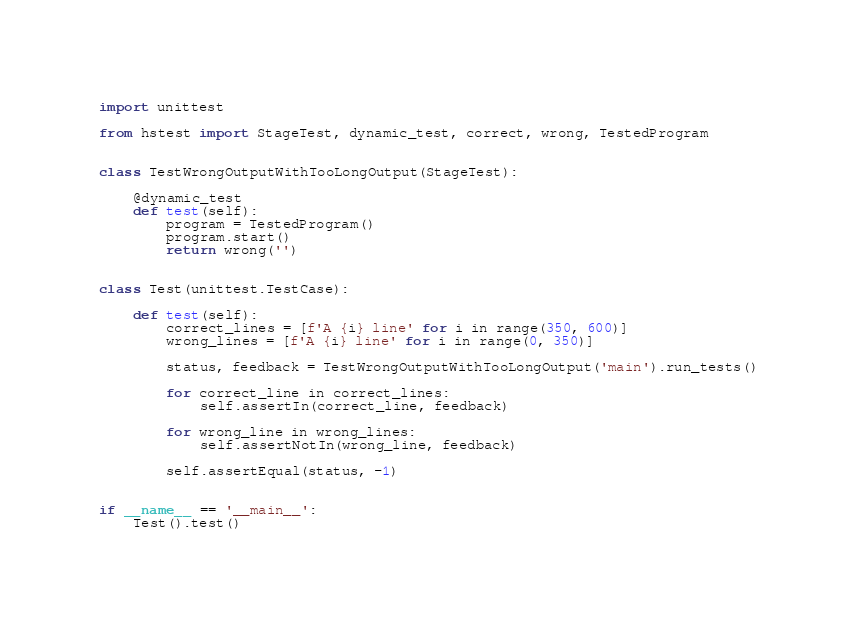<code> <loc_0><loc_0><loc_500><loc_500><_Python_>import unittest

from hstest import StageTest, dynamic_test, correct, wrong, TestedProgram


class TestWrongOutputWithTooLongOutput(StageTest):

    @dynamic_test
    def test(self):
        program = TestedProgram()
        program.start()
        return wrong('')


class Test(unittest.TestCase):

    def test(self):
        correct_lines = [f'A {i} line' for i in range(350, 600)]
        wrong_lines = [f'A {i} line' for i in range(0, 350)]

        status, feedback = TestWrongOutputWithTooLongOutput('main').run_tests()

        for correct_line in correct_lines:
            self.assertIn(correct_line, feedback)

        for wrong_line in wrong_lines:
            self.assertNotIn(wrong_line, feedback)

        self.assertEqual(status, -1)


if __name__ == '__main__':
    Test().test()
</code> 